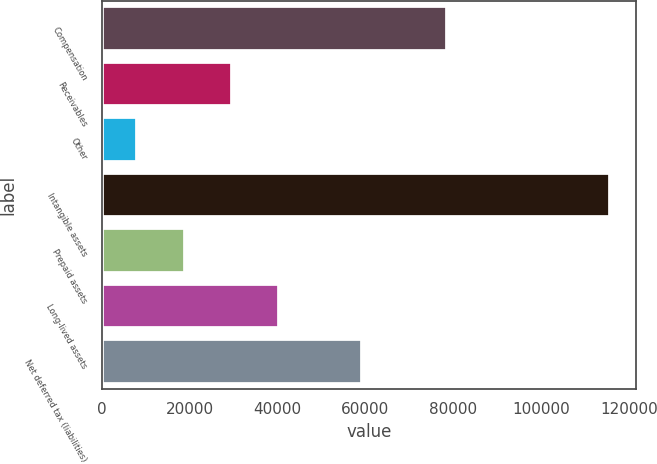Convert chart. <chart><loc_0><loc_0><loc_500><loc_500><bar_chart><fcel>Compensation<fcel>Receivables<fcel>Other<fcel>Intangible assets<fcel>Prepaid assets<fcel>Long-lived assets<fcel>Net deferred tax (liabilities)<nl><fcel>78516<fcel>29634.6<fcel>8103<fcel>115761<fcel>18868.8<fcel>40400.4<fcel>59215<nl></chart> 